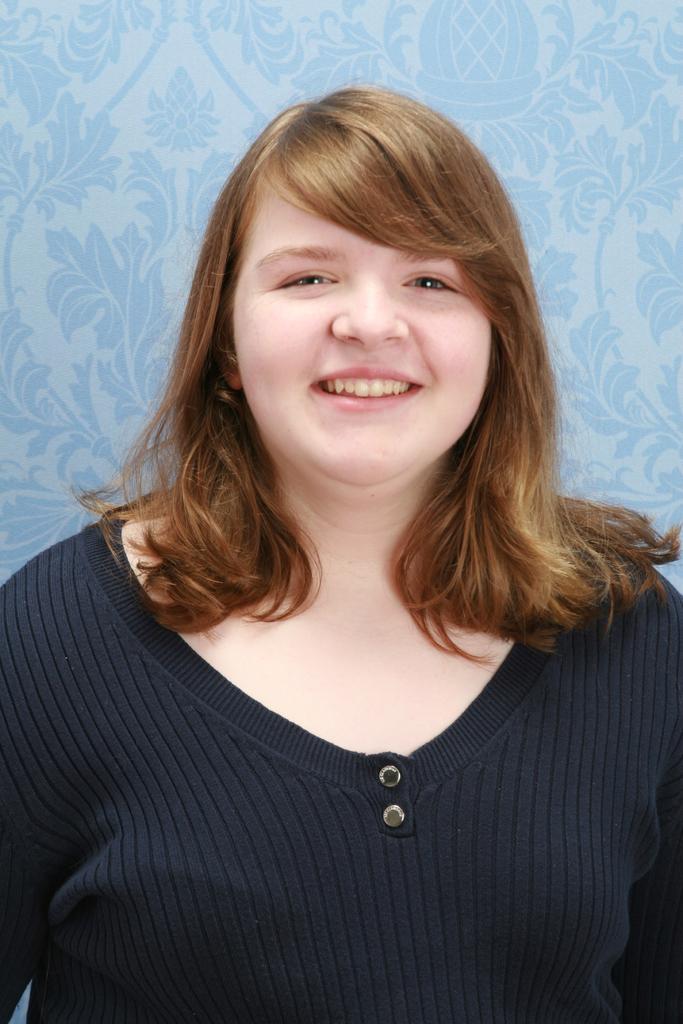Describe this image in one or two sentences. In this image I can see a person wearing a black color t-shirt ,she is smiling and the back ground is blue 